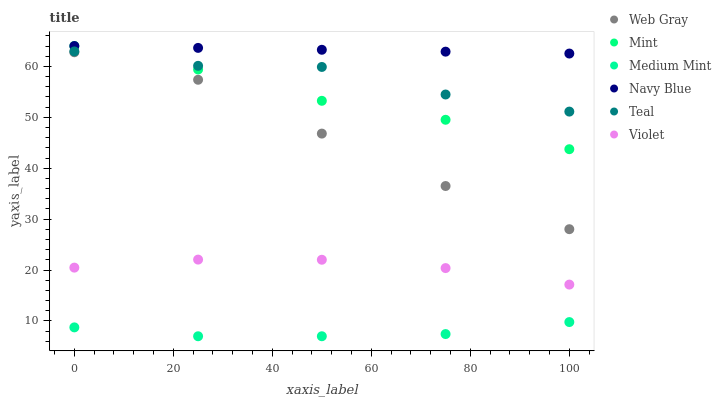Does Medium Mint have the minimum area under the curve?
Answer yes or no. Yes. Does Navy Blue have the maximum area under the curve?
Answer yes or no. Yes. Does Web Gray have the minimum area under the curve?
Answer yes or no. No. Does Web Gray have the maximum area under the curve?
Answer yes or no. No. Is Navy Blue the smoothest?
Answer yes or no. Yes. Is Teal the roughest?
Answer yes or no. Yes. Is Web Gray the smoothest?
Answer yes or no. No. Is Web Gray the roughest?
Answer yes or no. No. Does Medium Mint have the lowest value?
Answer yes or no. Yes. Does Web Gray have the lowest value?
Answer yes or no. No. Does Mint have the highest value?
Answer yes or no. Yes. Does Web Gray have the highest value?
Answer yes or no. No. Is Violet less than Web Gray?
Answer yes or no. Yes. Is Web Gray greater than Violet?
Answer yes or no. Yes. Does Mint intersect Teal?
Answer yes or no. Yes. Is Mint less than Teal?
Answer yes or no. No. Is Mint greater than Teal?
Answer yes or no. No. Does Violet intersect Web Gray?
Answer yes or no. No. 